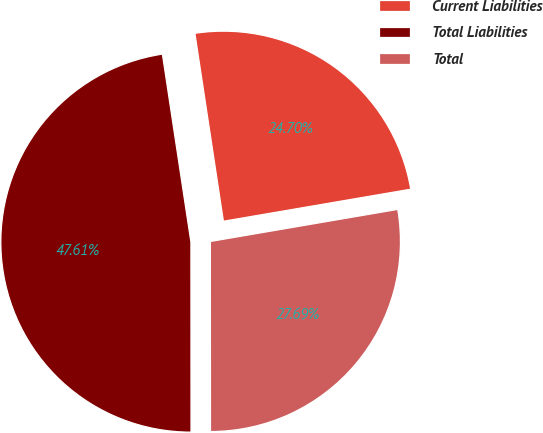Convert chart. <chart><loc_0><loc_0><loc_500><loc_500><pie_chart><fcel>Current Liabilities<fcel>Total Liabilities<fcel>Total<nl><fcel>24.7%<fcel>47.61%<fcel>27.69%<nl></chart> 